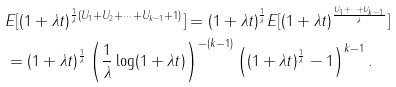<formula> <loc_0><loc_0><loc_500><loc_500>& E [ ( 1 + \lambda t ) ^ { \frac { 1 } { \lambda } ( U _ { 1 } + U _ { 2 } + \cdots + U _ { k - 1 } + 1 ) } ] = ( 1 + \lambda t ) ^ { \frac { 1 } { \lambda } } E [ ( 1 + \lambda t ) ^ { \frac { U _ { 1 } + \cdots + U _ { k - 1 } } { \lambda } } ] \\ & = ( 1 + \lambda t ) ^ { \frac { 1 } { \lambda } } \left ( \frac { 1 } { \lambda } \log ( 1 + \lambda t ) \right ) ^ { - ( k - 1 ) } \left ( ( 1 + \lambda t ) ^ { \frac { 1 } { \lambda } } - 1 \right ) ^ { k - 1 } .</formula> 